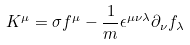<formula> <loc_0><loc_0><loc_500><loc_500>K ^ { \mu } = { \sigma } f ^ { \mu } - \frac { 1 } { m } \epsilon ^ { \mu \nu \lambda } \partial _ { \nu } f _ { \lambda }</formula> 